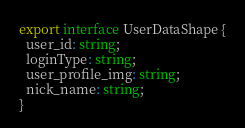Convert code to text. <code><loc_0><loc_0><loc_500><loc_500><_TypeScript_>export interface UserDataShape {
  user_id: string;
  loginType: string;
  user_profile_img: string;
  nick_name: string;
}
</code> 